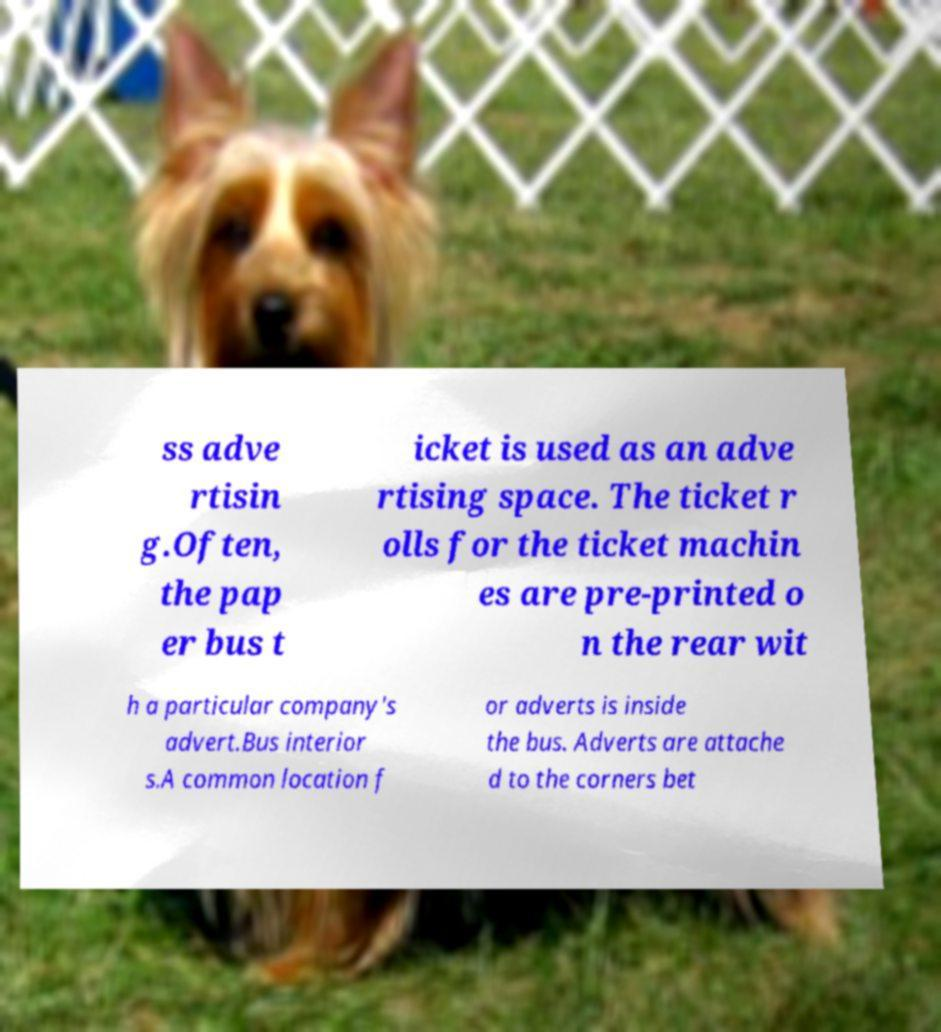Can you accurately transcribe the text from the provided image for me? ss adve rtisin g.Often, the pap er bus t icket is used as an adve rtising space. The ticket r olls for the ticket machin es are pre-printed o n the rear wit h a particular company's advert.Bus interior s.A common location f or adverts is inside the bus. Adverts are attache d to the corners bet 